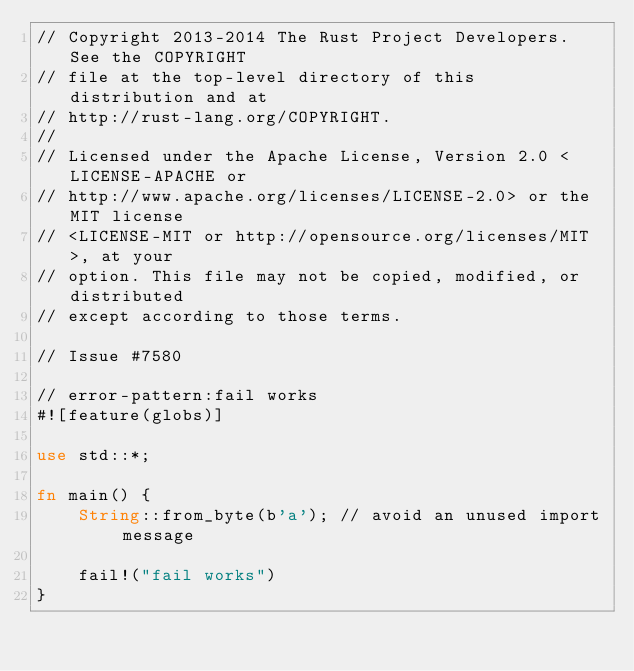Convert code to text. <code><loc_0><loc_0><loc_500><loc_500><_Rust_>// Copyright 2013-2014 The Rust Project Developers. See the COPYRIGHT
// file at the top-level directory of this distribution and at
// http://rust-lang.org/COPYRIGHT.
//
// Licensed under the Apache License, Version 2.0 <LICENSE-APACHE or
// http://www.apache.org/licenses/LICENSE-2.0> or the MIT license
// <LICENSE-MIT or http://opensource.org/licenses/MIT>, at your
// option. This file may not be copied, modified, or distributed
// except according to those terms.

// Issue #7580

// error-pattern:fail works
#![feature(globs)]

use std::*;

fn main() {
    String::from_byte(b'a'); // avoid an unused import message

    fail!("fail works")
}
</code> 